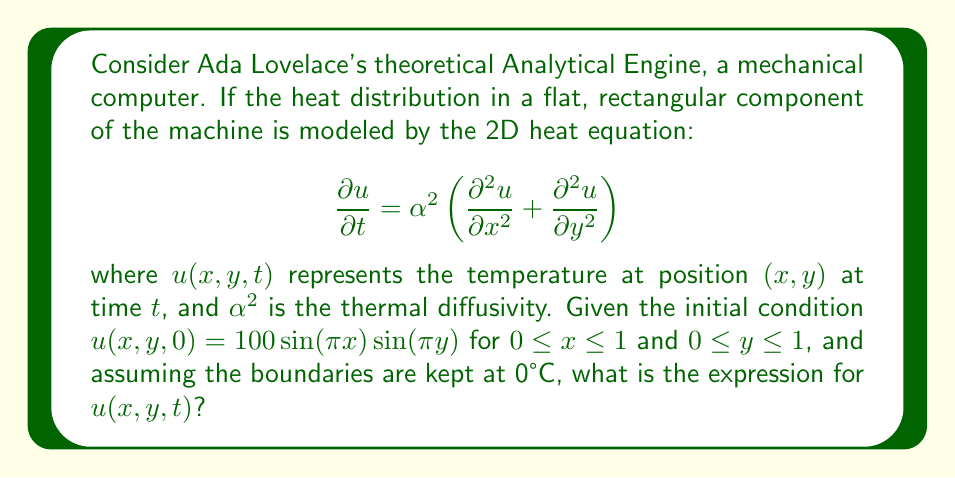Could you help me with this problem? To solve this problem, we'll use the method of separation of variables:

1) Assume a solution of the form: $u(x,y,t) = X(x)Y(y)T(t)$

2) Substituting this into the heat equation:

   $$XYT' = \alpha^2(X''YT + XY''T)$$

3) Dividing by $XYT$:

   $$\frac{T'}{T} = \alpha^2\left(\frac{X''}{X} + \frac{Y''}{Y}\right)$$

4) The left side is a function of $t$ only, and the right side is a function of $x$ and $y$ only. For this to be true, both sides must equal a constant, say $-\lambda^2$:

   $$\frac{T'}{T} = -\lambda^2$$
   $$\frac{X''}{X} + \frac{Y''}{Y} = -\frac{\lambda^2}{\alpha^2}$$

5) From the equation for $T$:
   
   $$T(t) = Ce^{-\lambda^2t}$$

6) The equation for $X$ and $Y$ can be separated:

   $$\frac{X''}{X} = -k^2, \frac{Y''}{Y} = -m^2$$
   where $k^2 + m^2 = \frac{\lambda^2}{\alpha^2}$

7) Solving these ODEs with the boundary conditions:

   $$X(x) = \sin(k\pi x), Y(y) = \sin(m\pi y)$$
   where $k$ and $m$ are positive integers.

8) The general solution is:

   $$u(x,y,t) = \sum_{k=1}^{\infty}\sum_{m=1}^{\infty}A_{km}\sin(k\pi x)\sin(m\pi y)e^{-\alpha^2(k^2+m^2)\pi^2t}$$

9) Using the initial condition to find $A_{km}$:

   $$100\sin(\pi x)\sin(\pi y) = \sum_{k=1}^{\infty}\sum_{m=1}^{\infty}A_{km}\sin(k\pi x)\sin(m\pi y)$$

10) This is satisfied when $k=m=1$ and $A_{11} = 100$, with all other $A_{km} = 0$.

Therefore, the solution is:

$$u(x,y,t) = 100\sin(\pi x)\sin(\pi y)e^{-2\alpha^2\pi^2t}$$
Answer: $u(x,y,t) = 100\sin(\pi x)\sin(\pi y)e^{-2\alpha^2\pi^2t}$ 